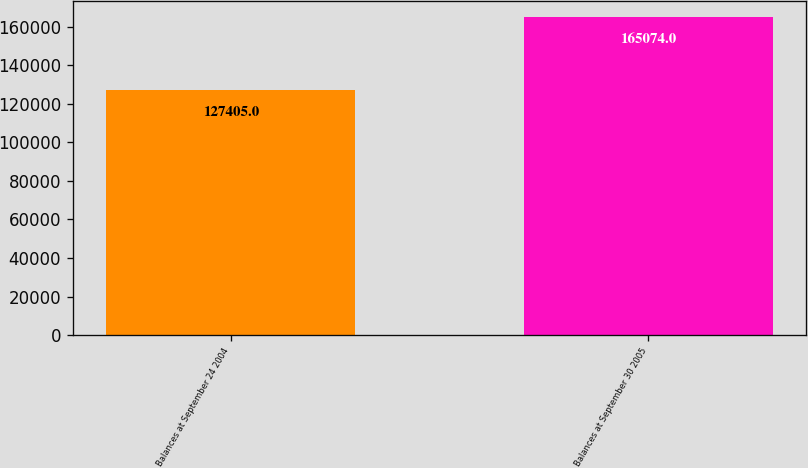<chart> <loc_0><loc_0><loc_500><loc_500><bar_chart><fcel>Balances at September 24 2004<fcel>Balances at September 30 2005<nl><fcel>127405<fcel>165074<nl></chart> 